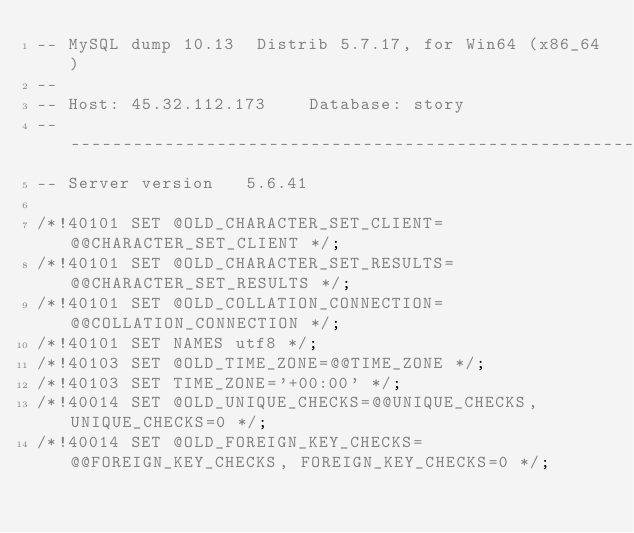Convert code to text. <code><loc_0><loc_0><loc_500><loc_500><_SQL_>-- MySQL dump 10.13  Distrib 5.7.17, for Win64 (x86_64)
--
-- Host: 45.32.112.173    Database: story
-- ------------------------------------------------------
-- Server version	5.6.41

/*!40101 SET @OLD_CHARACTER_SET_CLIENT=@@CHARACTER_SET_CLIENT */;
/*!40101 SET @OLD_CHARACTER_SET_RESULTS=@@CHARACTER_SET_RESULTS */;
/*!40101 SET @OLD_COLLATION_CONNECTION=@@COLLATION_CONNECTION */;
/*!40101 SET NAMES utf8 */;
/*!40103 SET @OLD_TIME_ZONE=@@TIME_ZONE */;
/*!40103 SET TIME_ZONE='+00:00' */;
/*!40014 SET @OLD_UNIQUE_CHECKS=@@UNIQUE_CHECKS, UNIQUE_CHECKS=0 */;
/*!40014 SET @OLD_FOREIGN_KEY_CHECKS=@@FOREIGN_KEY_CHECKS, FOREIGN_KEY_CHECKS=0 */;</code> 